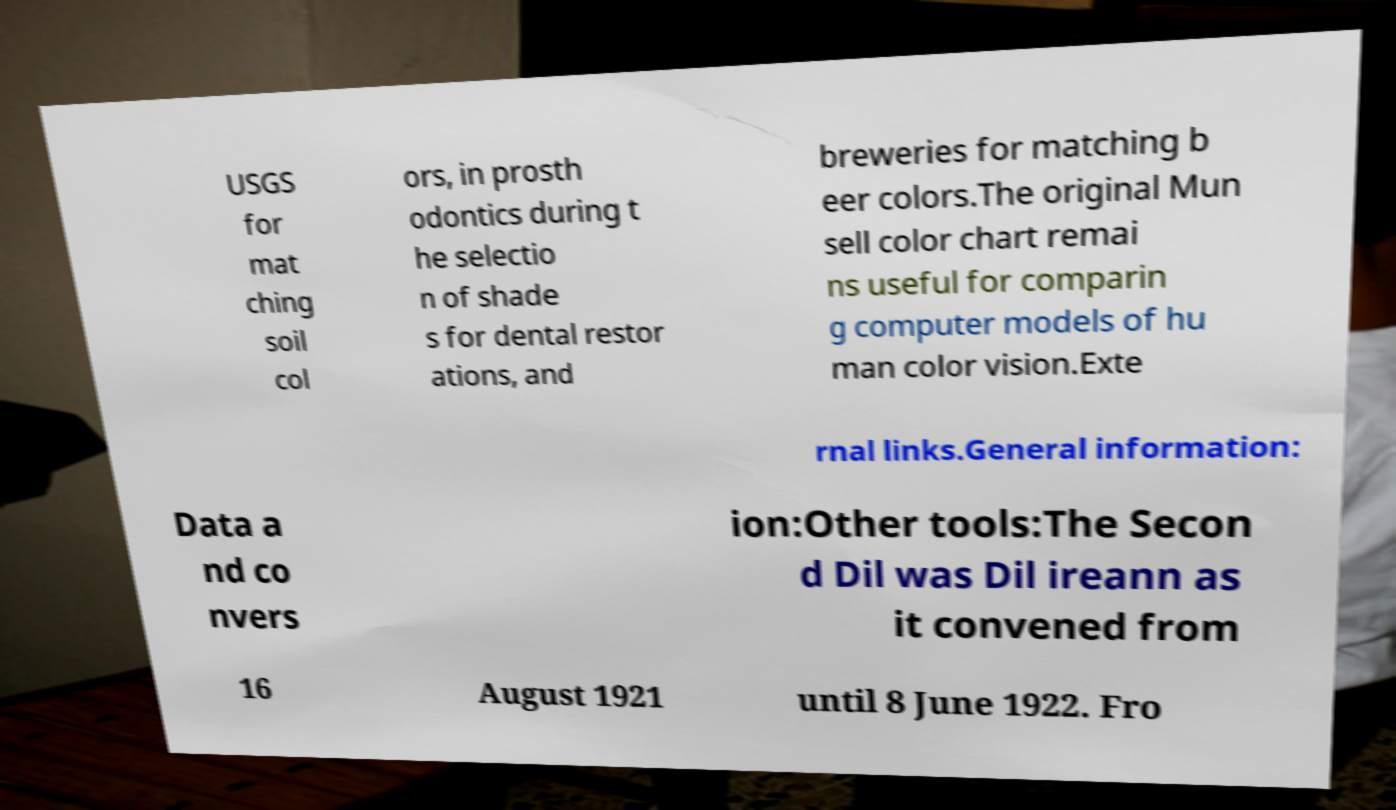There's text embedded in this image that I need extracted. Can you transcribe it verbatim? USGS for mat ching soil col ors, in prosth odontics during t he selectio n of shade s for dental restor ations, and breweries for matching b eer colors.The original Mun sell color chart remai ns useful for comparin g computer models of hu man color vision.Exte rnal links.General information: Data a nd co nvers ion:Other tools:The Secon d Dil was Dil ireann as it convened from 16 August 1921 until 8 June 1922. Fro 